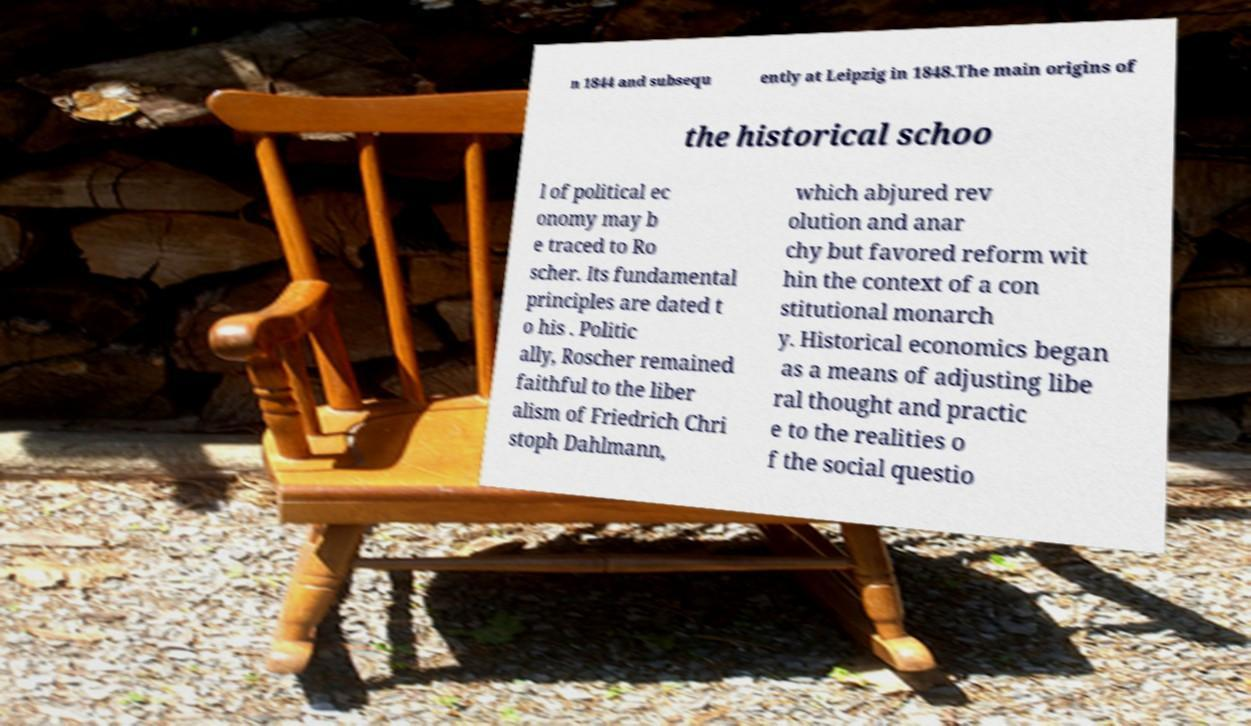There's text embedded in this image that I need extracted. Can you transcribe it verbatim? n 1844 and subsequ ently at Leipzig in 1848.The main origins of the historical schoo l of political ec onomy may b e traced to Ro scher. Its fundamental principles are dated t o his . Politic ally, Roscher remained faithful to the liber alism of Friedrich Chri stoph Dahlmann, which abjured rev olution and anar chy but favored reform wit hin the context of a con stitutional monarch y. Historical economics began as a means of adjusting libe ral thought and practic e to the realities o f the social questio 